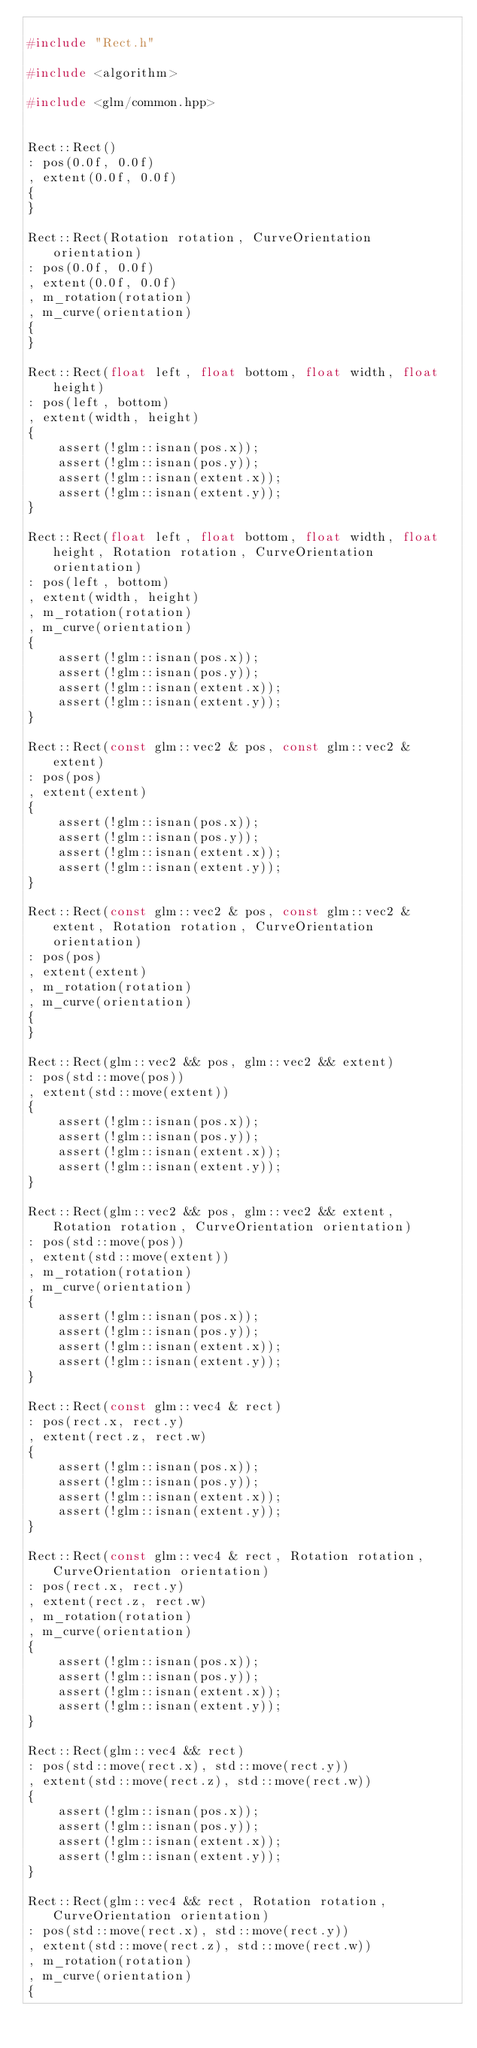<code> <loc_0><loc_0><loc_500><loc_500><_C++_>
#include "Rect.h"

#include <algorithm>

#include <glm/common.hpp>


Rect::Rect()
: pos(0.0f, 0.0f)
, extent(0.0f, 0.0f)
{
}

Rect::Rect(Rotation rotation, CurveOrientation orientation)
: pos(0.0f, 0.0f)
, extent(0.0f, 0.0f)
, m_rotation(rotation)
, m_curve(orientation)
{
}

Rect::Rect(float left, float bottom, float width, float height)
: pos(left, bottom)
, extent(width, height)
{
    assert(!glm::isnan(pos.x));
    assert(!glm::isnan(pos.y));
    assert(!glm::isnan(extent.x));
    assert(!glm::isnan(extent.y));
}

Rect::Rect(float left, float bottom, float width, float height, Rotation rotation, CurveOrientation orientation)
: pos(left, bottom)
, extent(width, height)
, m_rotation(rotation)
, m_curve(orientation)
{
    assert(!glm::isnan(pos.x));
    assert(!glm::isnan(pos.y));
    assert(!glm::isnan(extent.x));
    assert(!glm::isnan(extent.y));
}

Rect::Rect(const glm::vec2 & pos, const glm::vec2 & extent)
: pos(pos)
, extent(extent)
{
    assert(!glm::isnan(pos.x));
    assert(!glm::isnan(pos.y));
    assert(!glm::isnan(extent.x));
    assert(!glm::isnan(extent.y));
}

Rect::Rect(const glm::vec2 & pos, const glm::vec2 & extent, Rotation rotation, CurveOrientation orientation)
: pos(pos)
, extent(extent)
, m_rotation(rotation)
, m_curve(orientation)
{
}

Rect::Rect(glm::vec2 && pos, glm::vec2 && extent)
: pos(std::move(pos))
, extent(std::move(extent))
{
    assert(!glm::isnan(pos.x));
    assert(!glm::isnan(pos.y));
    assert(!glm::isnan(extent.x));
    assert(!glm::isnan(extent.y));
}

Rect::Rect(glm::vec2 && pos, glm::vec2 && extent, Rotation rotation, CurveOrientation orientation)
: pos(std::move(pos))
, extent(std::move(extent))
, m_rotation(rotation)
, m_curve(orientation)
{
    assert(!glm::isnan(pos.x));
    assert(!glm::isnan(pos.y));
    assert(!glm::isnan(extent.x));
    assert(!glm::isnan(extent.y));
}

Rect::Rect(const glm::vec4 & rect)
: pos(rect.x, rect.y)
, extent(rect.z, rect.w)
{
    assert(!glm::isnan(pos.x));
    assert(!glm::isnan(pos.y));
    assert(!glm::isnan(extent.x));
    assert(!glm::isnan(extent.y));
}

Rect::Rect(const glm::vec4 & rect, Rotation rotation, CurveOrientation orientation)
: pos(rect.x, rect.y)
, extent(rect.z, rect.w)
, m_rotation(rotation)
, m_curve(orientation)
{
    assert(!glm::isnan(pos.x));
    assert(!glm::isnan(pos.y));
    assert(!glm::isnan(extent.x));
    assert(!glm::isnan(extent.y));
}

Rect::Rect(glm::vec4 && rect)
: pos(std::move(rect.x), std::move(rect.y))
, extent(std::move(rect.z), std::move(rect.w))
{
    assert(!glm::isnan(pos.x));
    assert(!glm::isnan(pos.y));
    assert(!glm::isnan(extent.x));
    assert(!glm::isnan(extent.y));
}

Rect::Rect(glm::vec4 && rect, Rotation rotation, CurveOrientation orientation)
: pos(std::move(rect.x), std::move(rect.y))
, extent(std::move(rect.z), std::move(rect.w))
, m_rotation(rotation)
, m_curve(orientation)
{</code> 